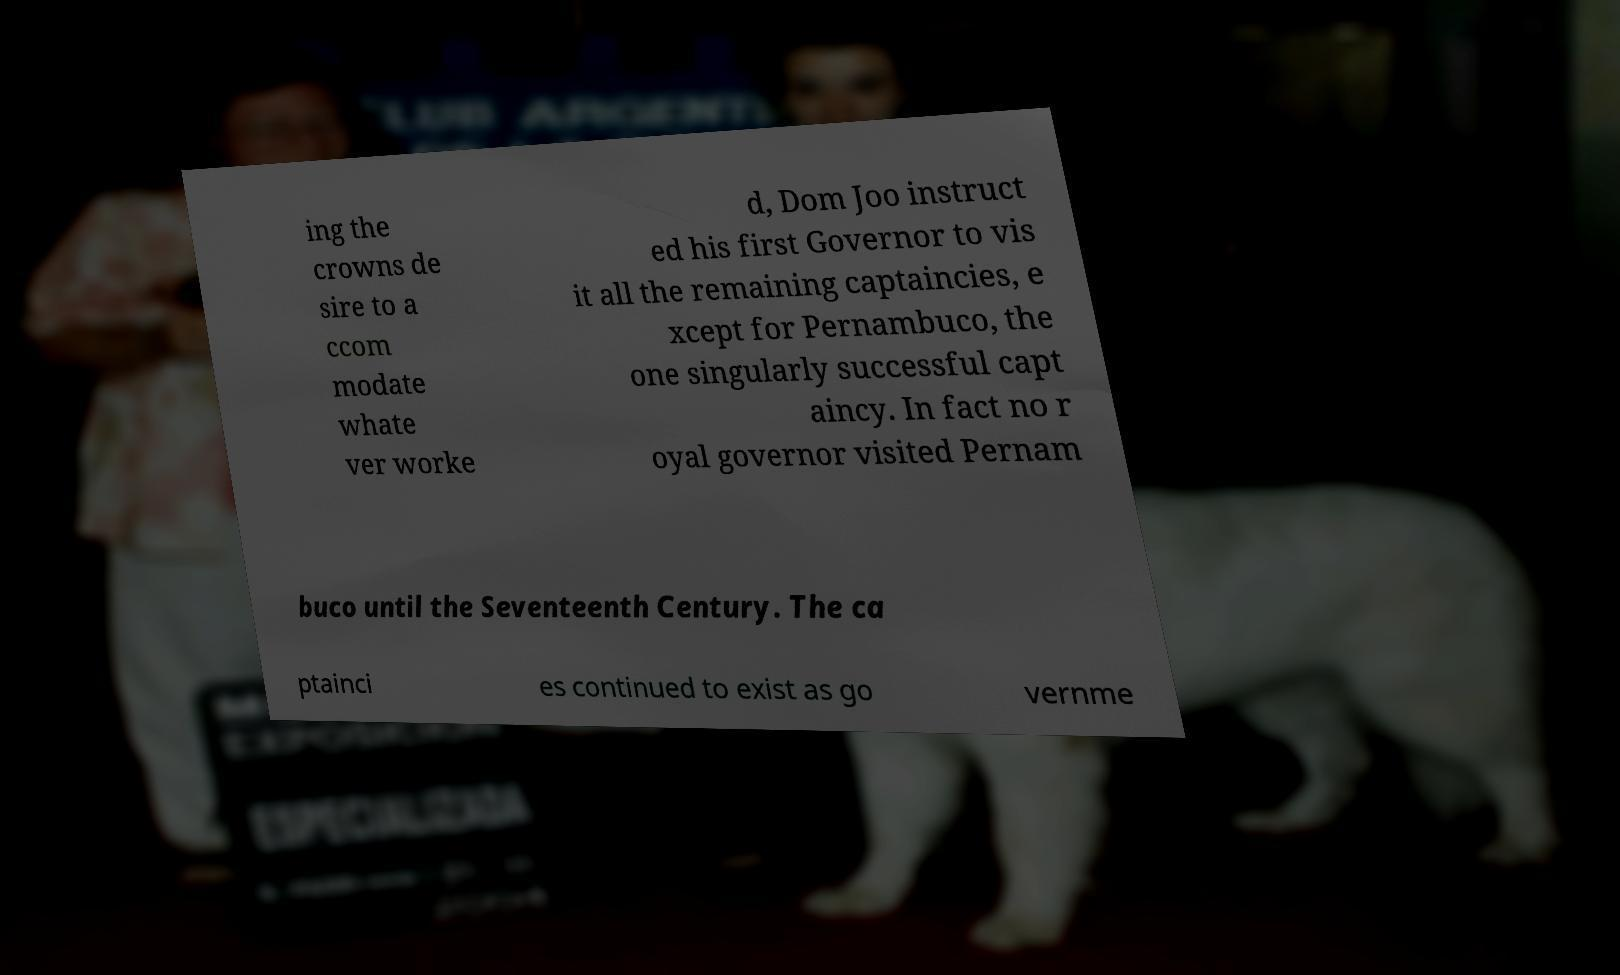Could you assist in decoding the text presented in this image and type it out clearly? ing the crowns de sire to a ccom modate whate ver worke d, Dom Joo instruct ed his first Governor to vis it all the remaining captaincies, e xcept for Pernambuco, the one singularly successful capt aincy. In fact no r oyal governor visited Pernam buco until the Seventeenth Century. The ca ptainci es continued to exist as go vernme 